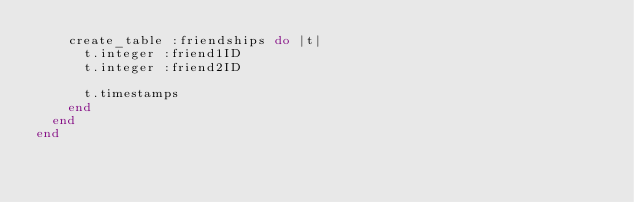<code> <loc_0><loc_0><loc_500><loc_500><_Ruby_>    create_table :friendships do |t|
      t.integer :friend1ID
      t.integer :friend2ID

      t.timestamps
    end
  end
end
</code> 